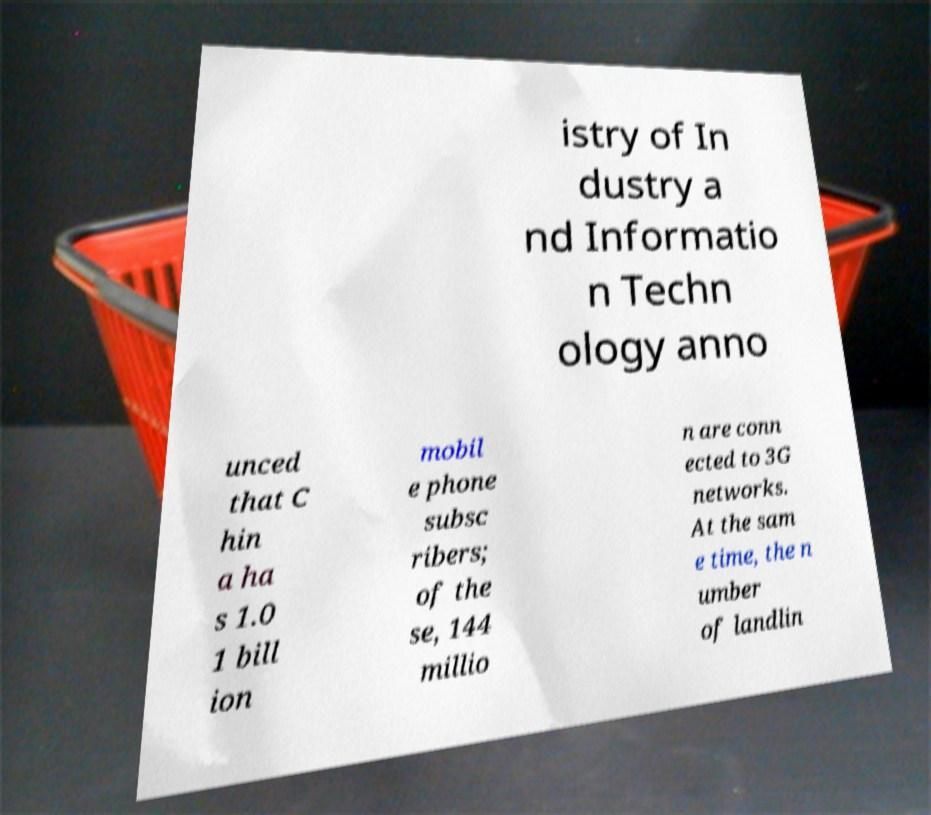Could you extract and type out the text from this image? istry of In dustry a nd Informatio n Techn ology anno unced that C hin a ha s 1.0 1 bill ion mobil e phone subsc ribers; of the se, 144 millio n are conn ected to 3G networks. At the sam e time, the n umber of landlin 